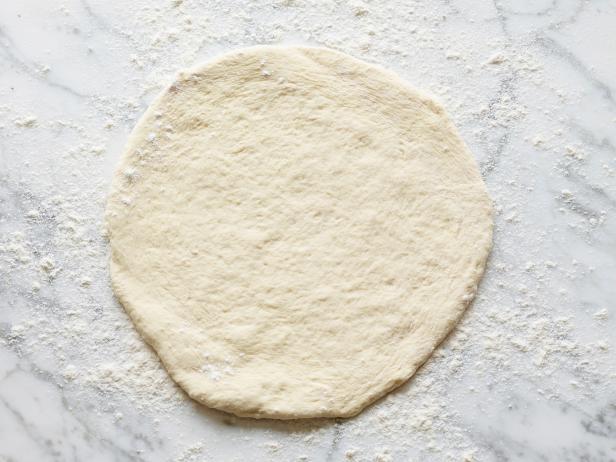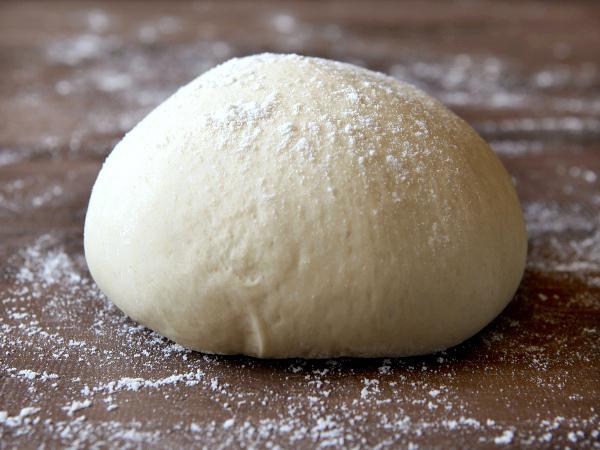The first image is the image on the left, the second image is the image on the right. Assess this claim about the two images: "The dough has been flattened into a pizza crust shape in only one of the images.". Correct or not? Answer yes or no. Yes. The first image is the image on the left, the second image is the image on the right. For the images shown, is this caption "In one image a ball of dough is resting on a flour-dusted surface, while a second image shows dough flattened into a round disk." true? Answer yes or no. Yes. 